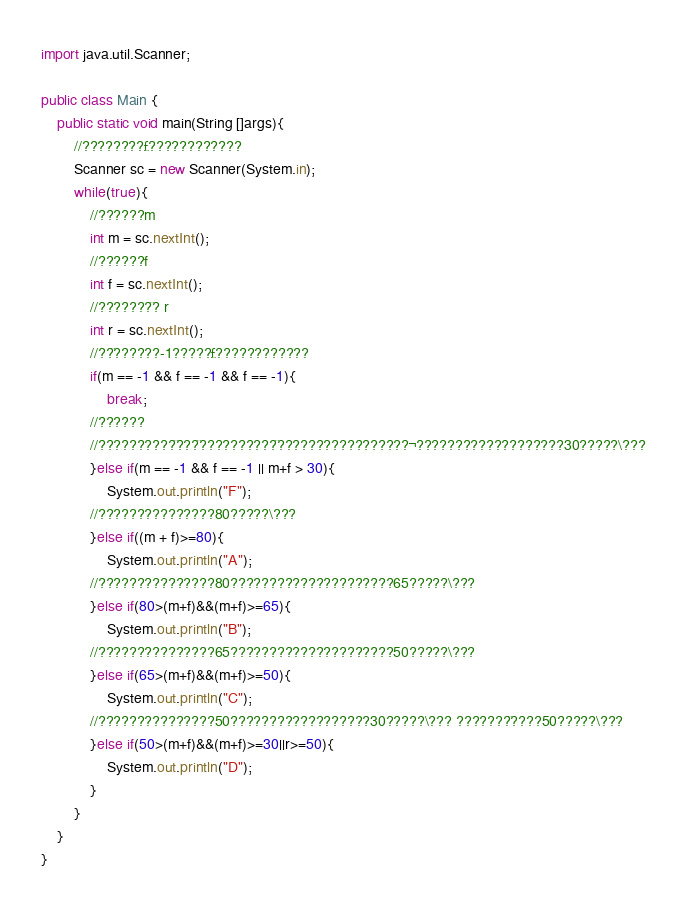Convert code to text. <code><loc_0><loc_0><loc_500><loc_500><_Java_>

import java.util.Scanner;

public class Main {
	public static void main(String []args){
		//????????£????????????
		Scanner sc = new Scanner(System.in);
		while(true){
			//??????m
			int m = sc.nextInt();
			//??????f
			int f = sc.nextInt();
			//???????¨? r
			int r = sc.nextInt();
			//??¨??????-1?????£????????????
			if(m == -1 && f == -1 && f == -1){
                break;
            //??????
            //??????????¨???¨??????????¨?????????????????¬???????????????????30?????\???
			}else if(m == -1 && f == -1 || m+f > 30){
				System.out.println("F");
			//???????????????80?????\???
			}else if((m + f)>=80){
				System.out.println("A");
			//???????????????80?????????????????????65?????\???
			}else if(80>(m+f)&&(m+f)>=65){
				System.out.println("B");
			//???????????????65?????????????????????50?????\???
			}else if(65>(m+f)&&(m+f)>=50){
				System.out.println("C");
			//???????????????50??????????????????30?????\??? ???????¨????50?????\???
			}else if(50>(m+f)&&(m+f)>=30||r>=50){
				System.out.println("D");
			}
		}
    }
}</code> 